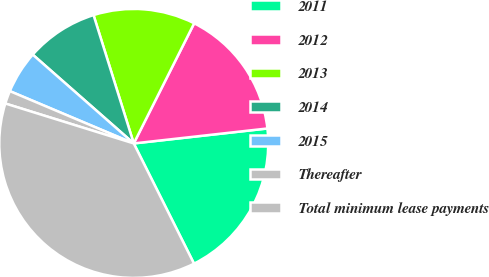Convert chart. <chart><loc_0><loc_0><loc_500><loc_500><pie_chart><fcel>2011<fcel>2012<fcel>2013<fcel>2014<fcel>2015<fcel>Thereafter<fcel>Total minimum lease payments<nl><fcel>19.38%<fcel>15.81%<fcel>12.25%<fcel>8.69%<fcel>5.12%<fcel>1.56%<fcel>37.19%<nl></chart> 